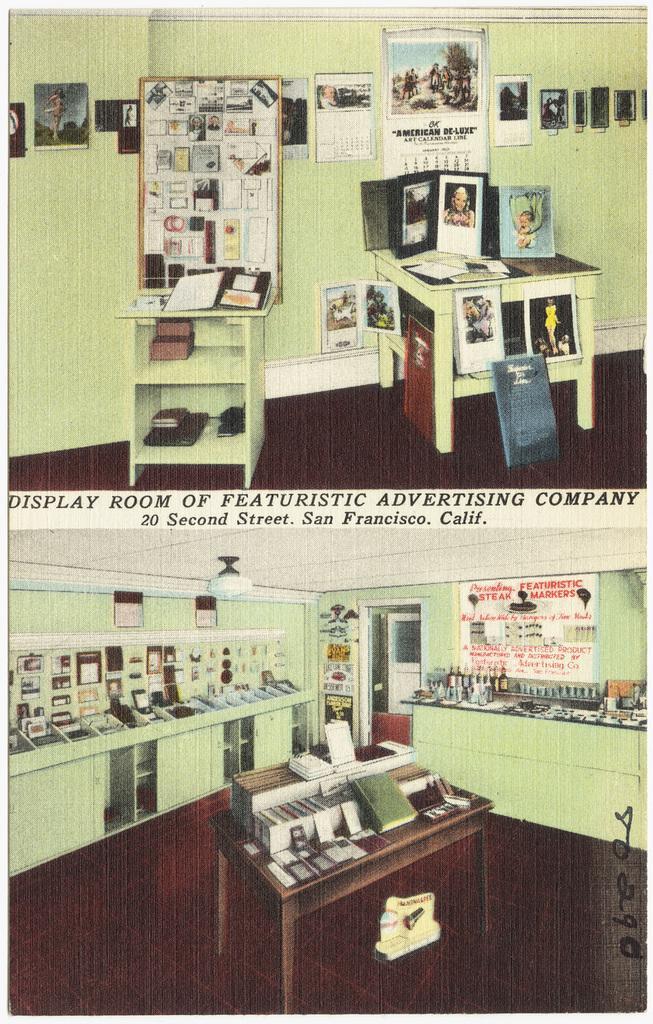Can you describe this image briefly? In the image I can the collage of two pictures in which there are some cupboards, shelves, tables in which there are some things placed and also I can see some frames to the wall. 